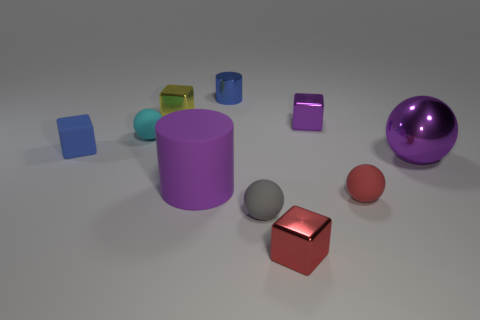What could be the purpose of this arrangement? This arrangement could be a part of a visual study or demonstration of shapes, colors, and reflections. It might be used for educational purposes, perhaps in a classroom setting to teach students about geometry, or in a design setting to examine color interaction and composition. Could this image have any artistic significance? Certainly, the arrangement of shapes and colors might also be appreciated from an artistic perspective, focusing on the balance and contrast within a minimalist composition, evoking a sense of modern simplicity and aesthetic pleasure. 